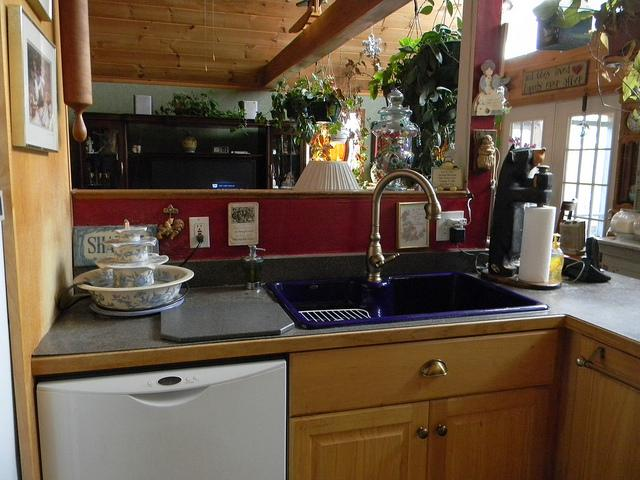What is on top of the counter? fountain 